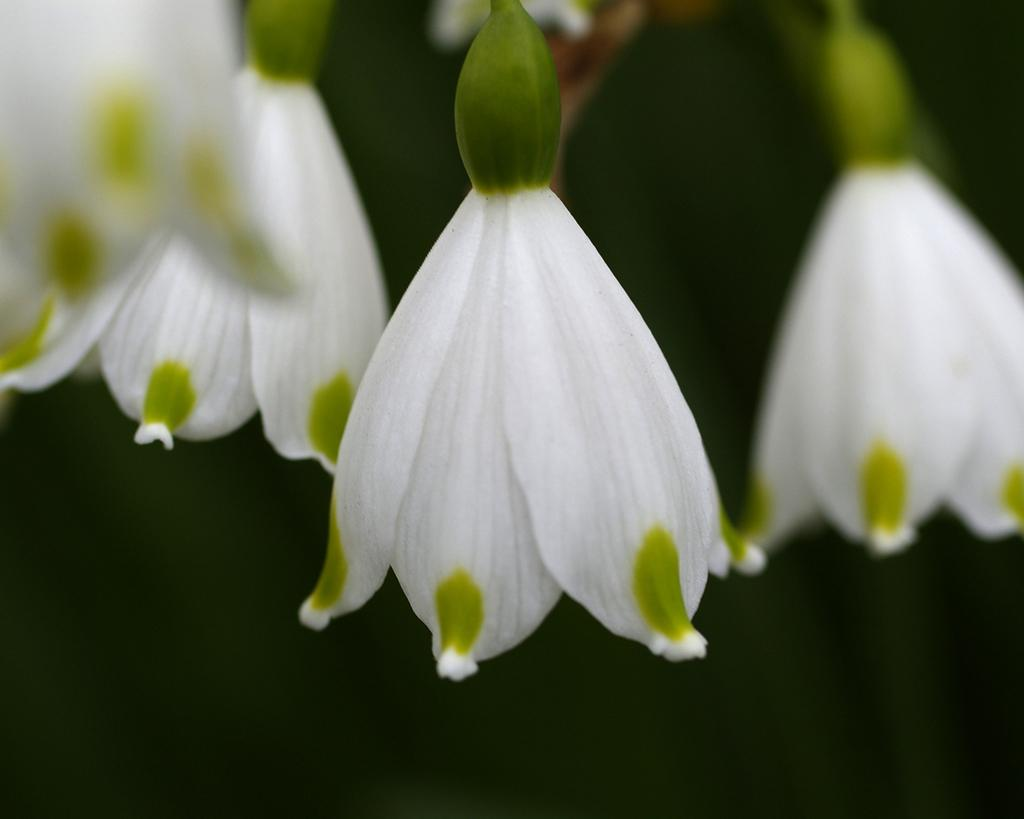What type of living organisms can be seen in the image? There are flowers in the image. Can you describe the background of the image? The background of the image is blurred. Where is the dad standing in the image? There is no dad present in the image. How many clouds can be seen in the image? There are no clouds visible in the image. What type of gathering of people can be seen in the image? There is no crowd present in the image. 